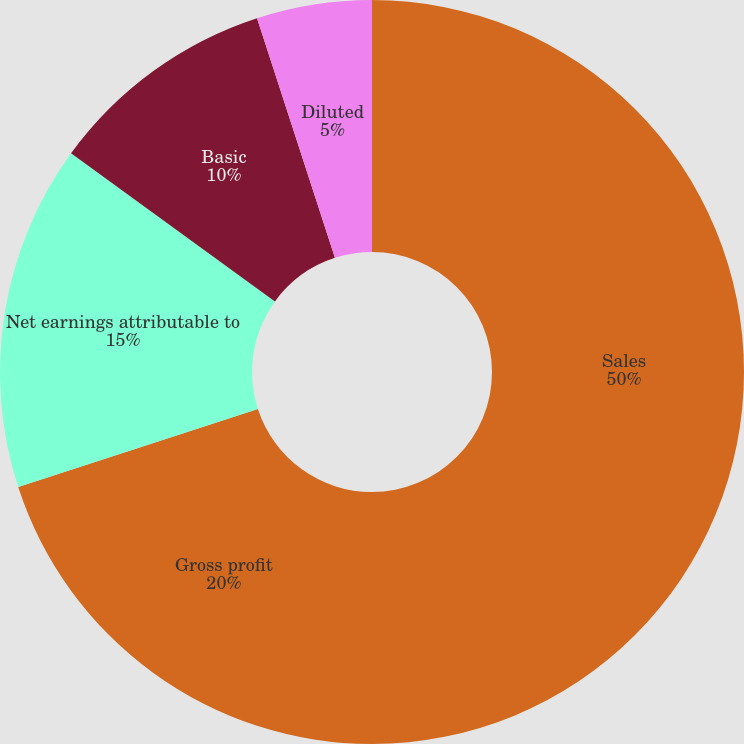Convert chart. <chart><loc_0><loc_0><loc_500><loc_500><pie_chart><fcel>Sales<fcel>Gross profit<fcel>Net earnings attributable to<fcel>Basic<fcel>Diluted<fcel>Cash dividends declared per<nl><fcel>50.0%<fcel>20.0%<fcel>15.0%<fcel>10.0%<fcel>5.0%<fcel>0.0%<nl></chart> 